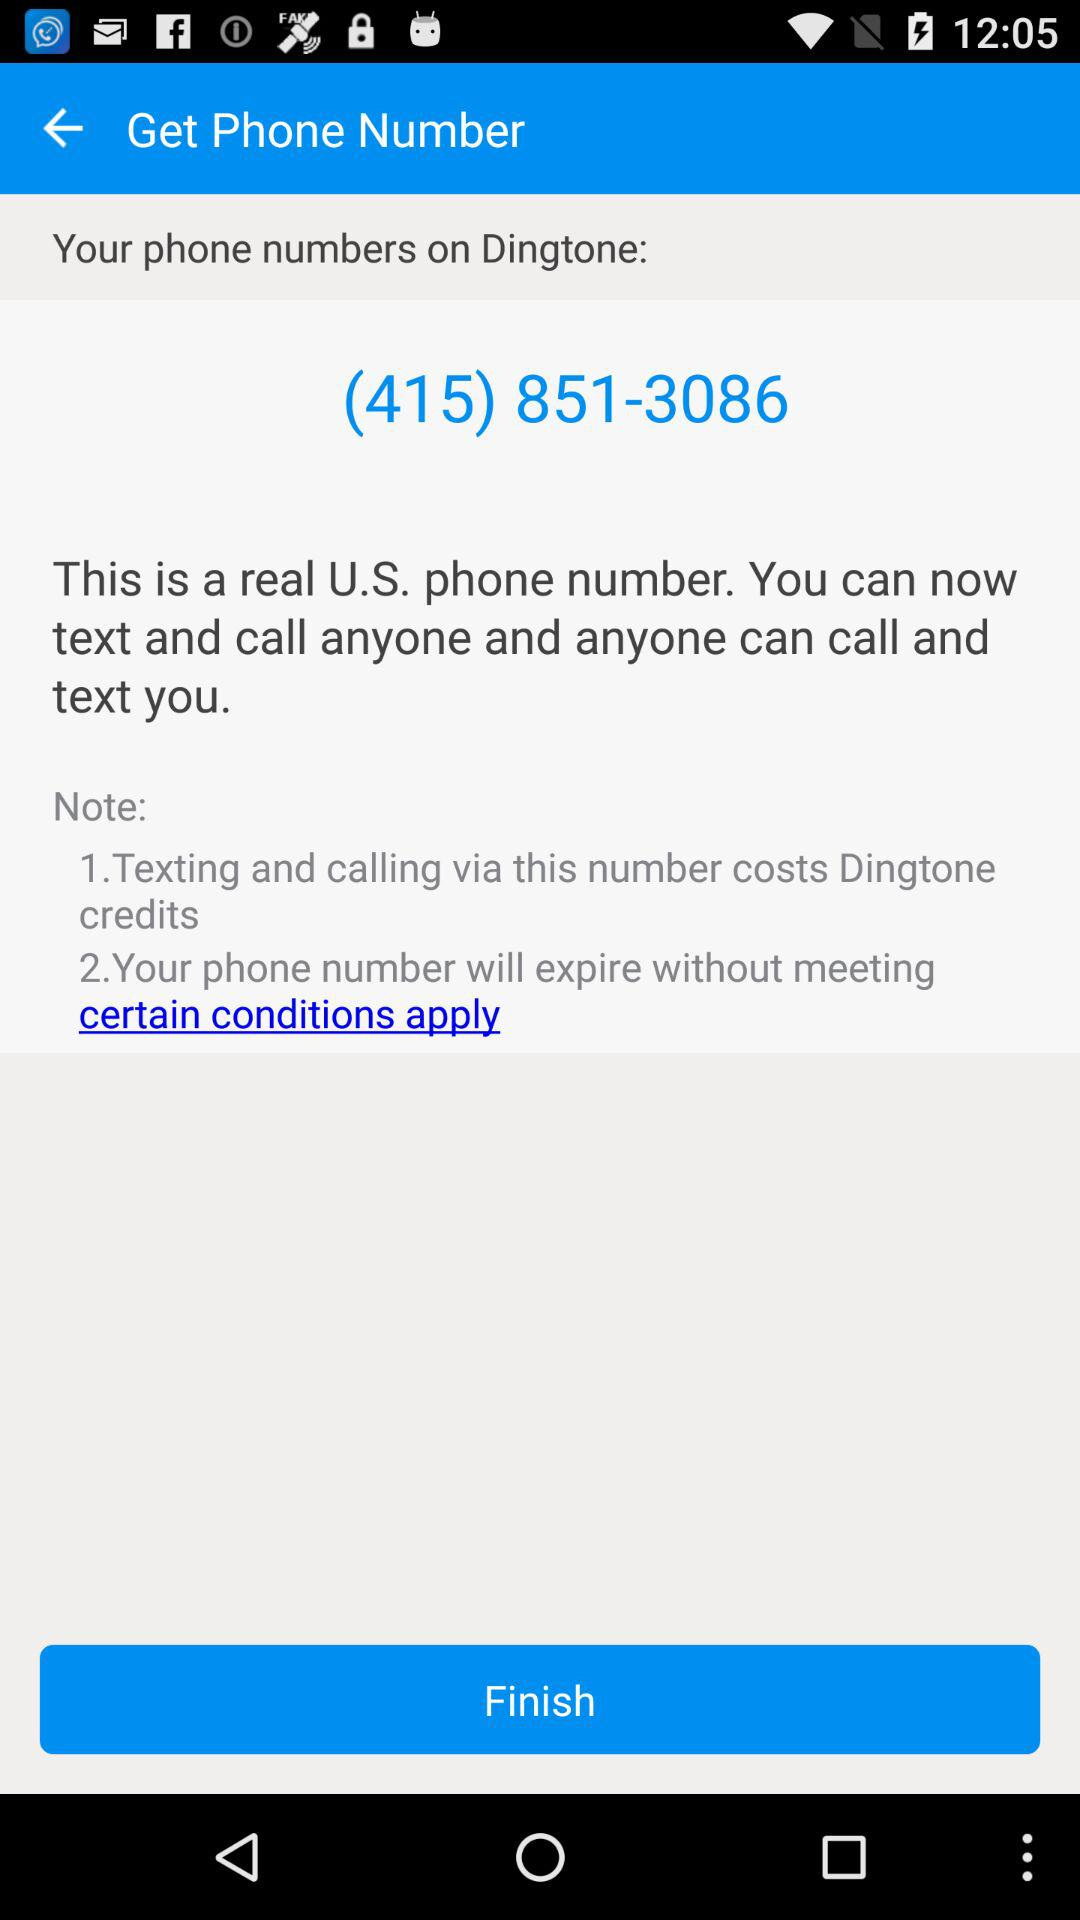How many conditions apply to the phone number?
Answer the question using a single word or phrase. 2 